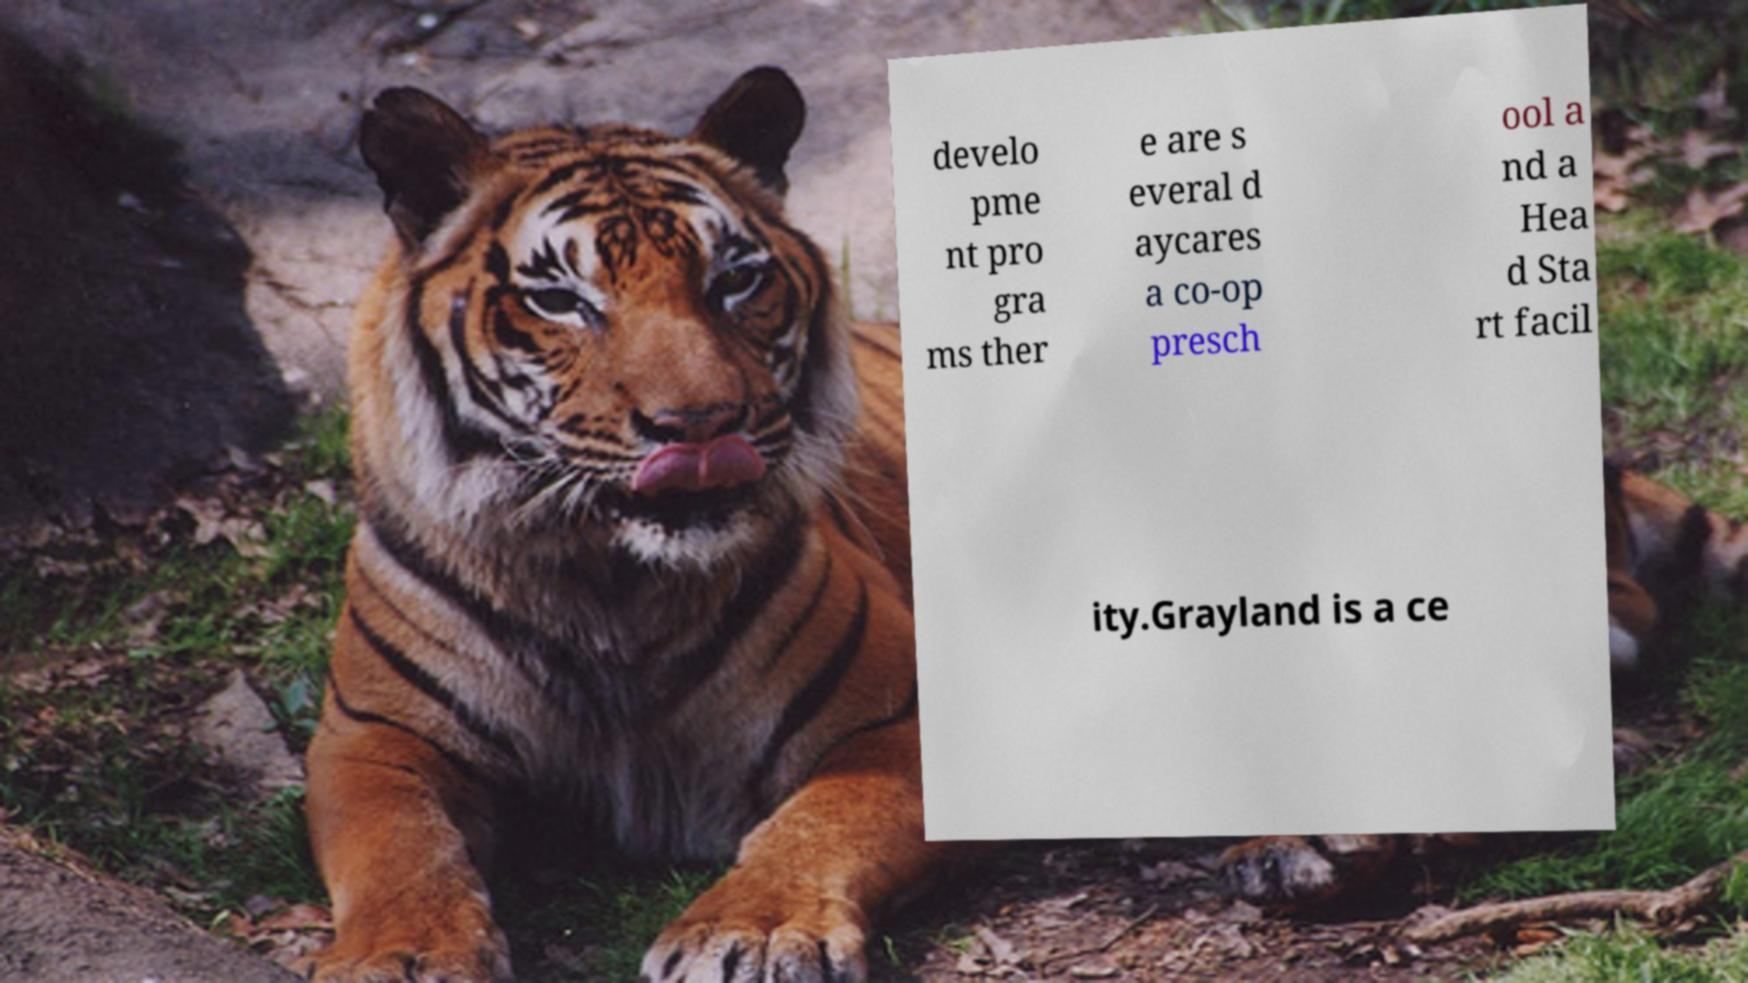Please read and relay the text visible in this image. What does it say? develo pme nt pro gra ms ther e are s everal d aycares a co-op presch ool a nd a Hea d Sta rt facil ity.Grayland is a ce 